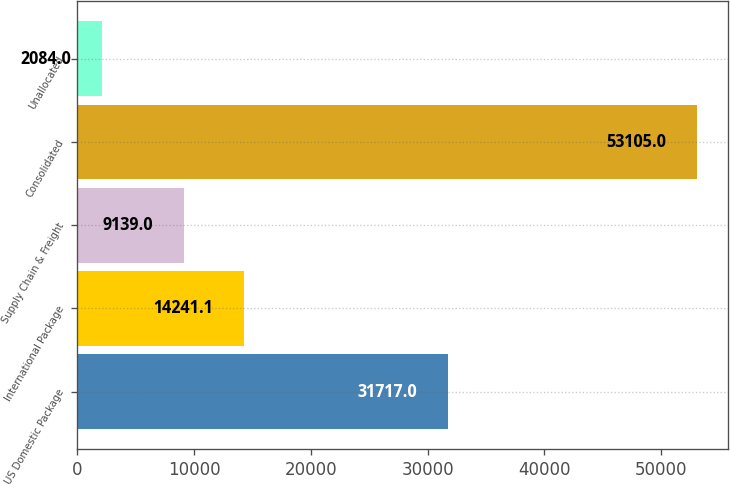Convert chart. <chart><loc_0><loc_0><loc_500><loc_500><bar_chart><fcel>US Domestic Package<fcel>International Package<fcel>Supply Chain & Freight<fcel>Consolidated<fcel>Unallocated<nl><fcel>31717<fcel>14241.1<fcel>9139<fcel>53105<fcel>2084<nl></chart> 